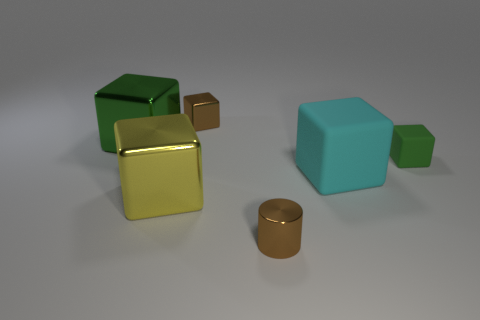Subtract all small matte cubes. How many cubes are left? 4 Add 2 big yellow shiny blocks. How many objects exist? 8 Subtract all green cubes. How many cubes are left? 3 Subtract 1 cylinders. How many cylinders are left? 0 Subtract all purple balls. How many green cubes are left? 2 Subtract all brown blocks. Subtract all large green things. How many objects are left? 4 Add 1 green shiny objects. How many green shiny objects are left? 2 Add 5 small gray balls. How many small gray balls exist? 5 Subtract 0 brown balls. How many objects are left? 6 Subtract all cubes. How many objects are left? 1 